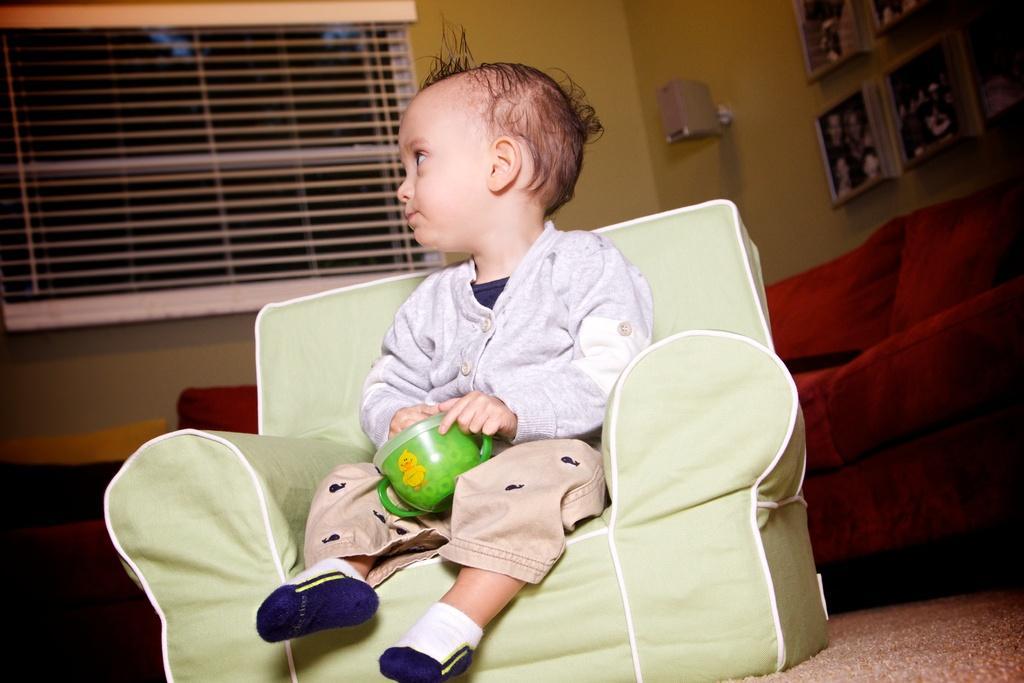Please provide a concise description of this image. There is a boy sitting on chair and holding a cup behind him there is a sofa and beside that there is a lamp and photo frames hanging on wall. 